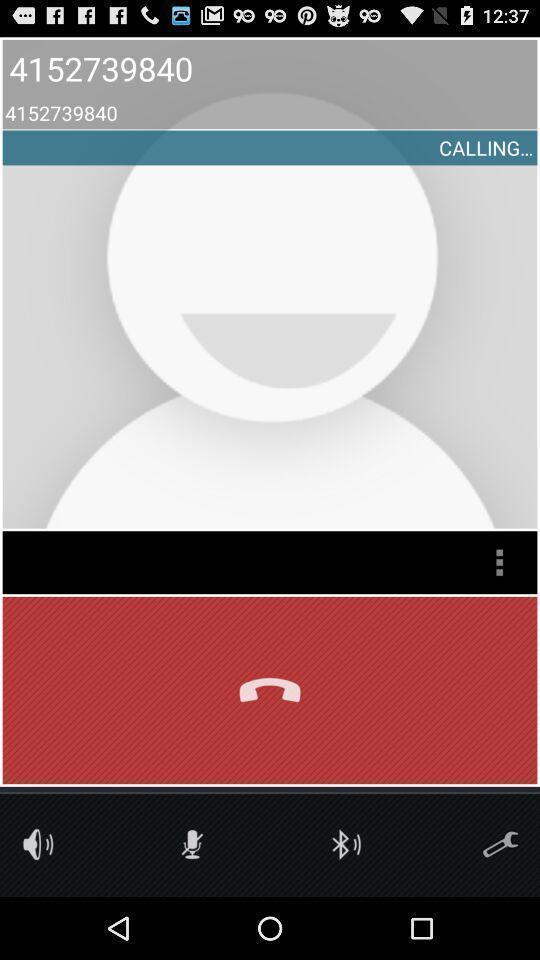Tell me what you see in this picture. Screen displaying calling a contact with multiple options. 